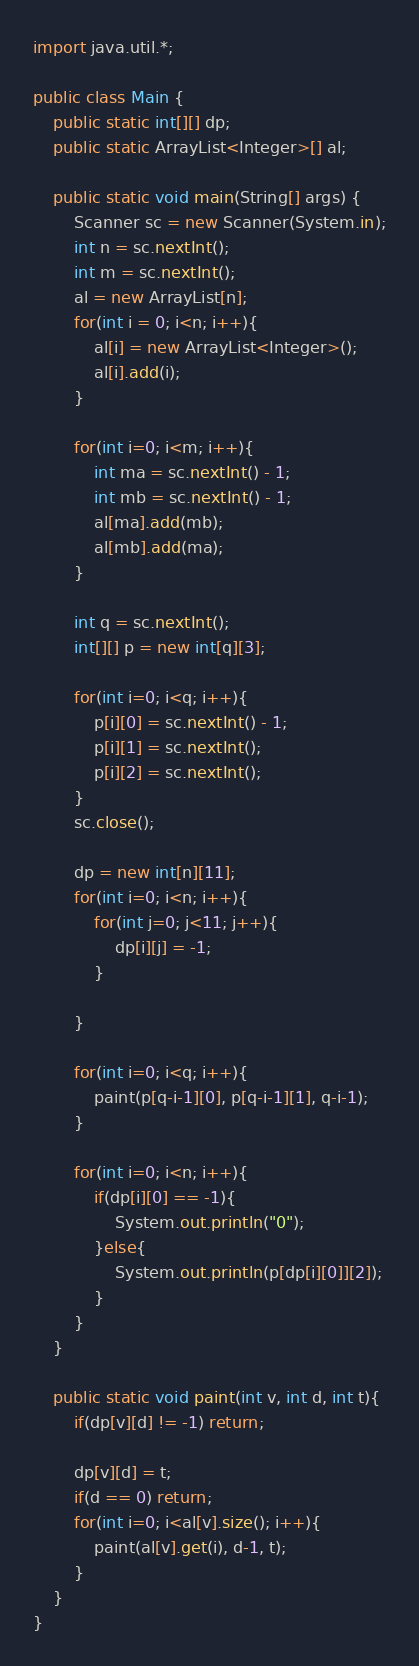<code> <loc_0><loc_0><loc_500><loc_500><_Java_>import java.util.*;

public class Main {
    public static int[][] dp;
    public static ArrayList<Integer>[] al;

    public static void main(String[] args) {
        Scanner sc = new Scanner(System.in);
        int n = sc.nextInt();
        int m = sc.nextInt();
        al = new ArrayList[n];
        for(int i = 0; i<n; i++){
            al[i] = new ArrayList<Integer>();
            al[i].add(i);
        }

        for(int i=0; i<m; i++){
            int ma = sc.nextInt() - 1;
            int mb = sc.nextInt() - 1;
            al[ma].add(mb);
            al[mb].add(ma);
        }

        int q = sc.nextInt();
        int[][] p = new int[q][3];

        for(int i=0; i<q; i++){
            p[i][0] = sc.nextInt() - 1;
            p[i][1] = sc.nextInt();
            p[i][2] = sc.nextInt();
        }
        sc.close();

        dp = new int[n][11];
        for(int i=0; i<n; i++){
            for(int j=0; j<11; j++){
                dp[i][j] = -1;
            }
            
        }

        for(int i=0; i<q; i++){
            paint(p[q-i-1][0], p[q-i-1][1], q-i-1);
        }

        for(int i=0; i<n; i++){
            if(dp[i][0] == -1){
                System.out.println("0");
            }else{
                System.out.println(p[dp[i][0]][2]);
            }
        }
    }

    public static void paint(int v, int d, int t){
        if(dp[v][d] != -1) return;

        dp[v][d] = t;
        if(d == 0) return;
        for(int i=0; i<al[v].size(); i++){
            paint(al[v].get(i), d-1, t);
        }
    }
}</code> 